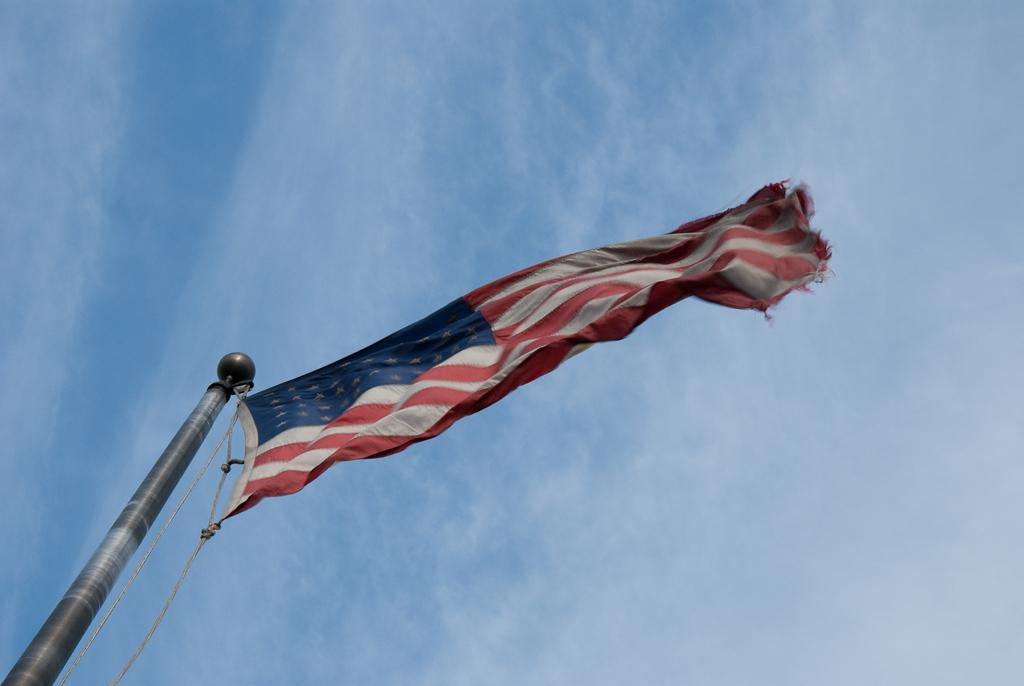What is the main object in the image? There is a flag in the image. How is the flag supported or held up? The flag is attached to a pole. What can be seen in the background of the image? There is a sky visible in the background of the image. Where is the throne located in the image? There is no throne present in the image. What type of hose can be seen connected to the flagpole in the image? There is no hose connected to the flagpole in the image. 